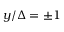<formula> <loc_0><loc_0><loc_500><loc_500>y / \Delta = \pm 1</formula> 